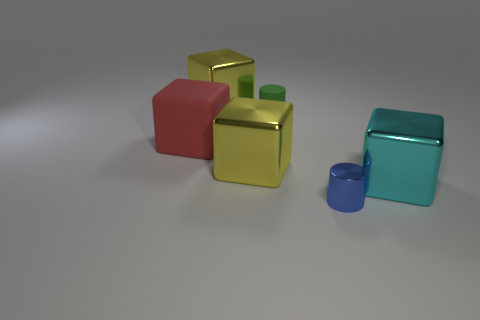Are there any small blue metallic cylinders?
Offer a terse response. Yes. What number of other things are there of the same material as the red thing
Provide a short and direct response. 1. What material is the other cyan block that is the same size as the matte cube?
Offer a terse response. Metal. There is a large yellow object behind the large red matte object; is its shape the same as the big matte thing?
Your answer should be compact. Yes. Do the tiny metallic thing and the big rubber object have the same color?
Keep it short and to the point. No. What number of things are either small cylinders in front of the big red matte object or yellow metallic things?
Your answer should be compact. 3. There is a cyan metallic object that is the same size as the red thing; what shape is it?
Provide a succinct answer. Cube. There is a thing right of the blue metal thing; is its size the same as the cylinder on the left side of the tiny metal cylinder?
Offer a terse response. No. There is a cylinder that is the same material as the big red cube; what is its color?
Your response must be concise. Green. Do the large yellow cube that is in front of the large matte block and the large cube that is to the right of the small green cylinder have the same material?
Provide a short and direct response. Yes. 